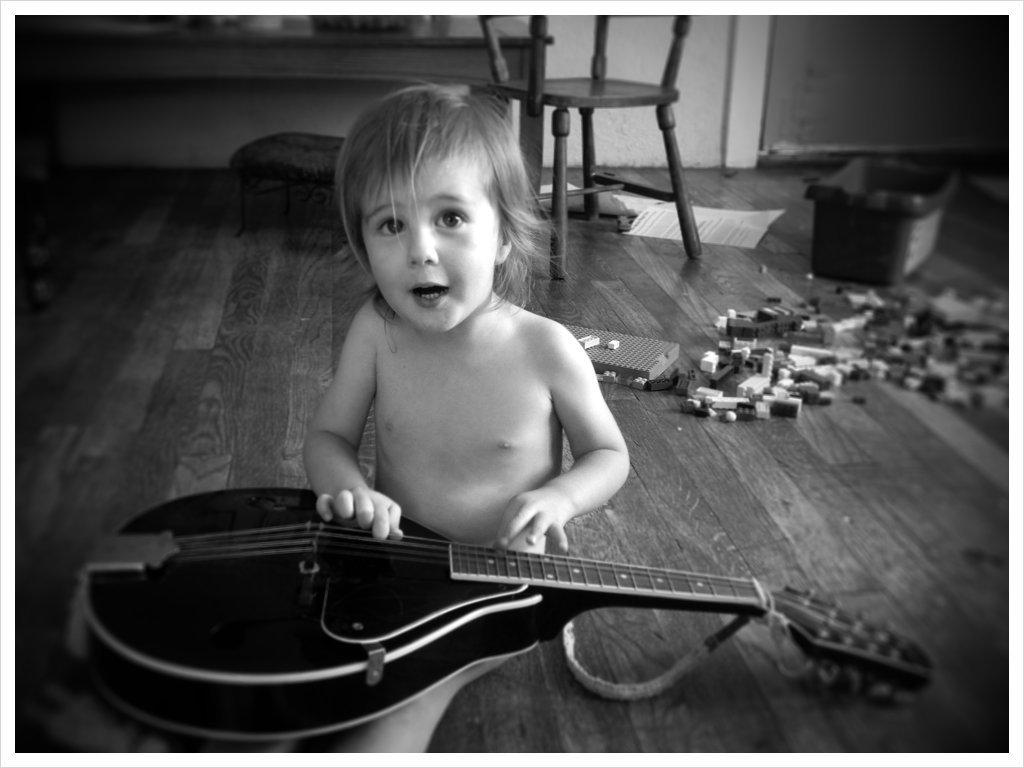What is the child in the image doing? The child is sitting on the ground and playing a guitar. What can be seen in the background of the image? There is a chair and a table in the background. What else is on the ground besides the child? There are toys on the ground. What type of mouth does the rain have in the image? There is no rain present in the image, so it is not possible to determine the type of mouth it might have. 